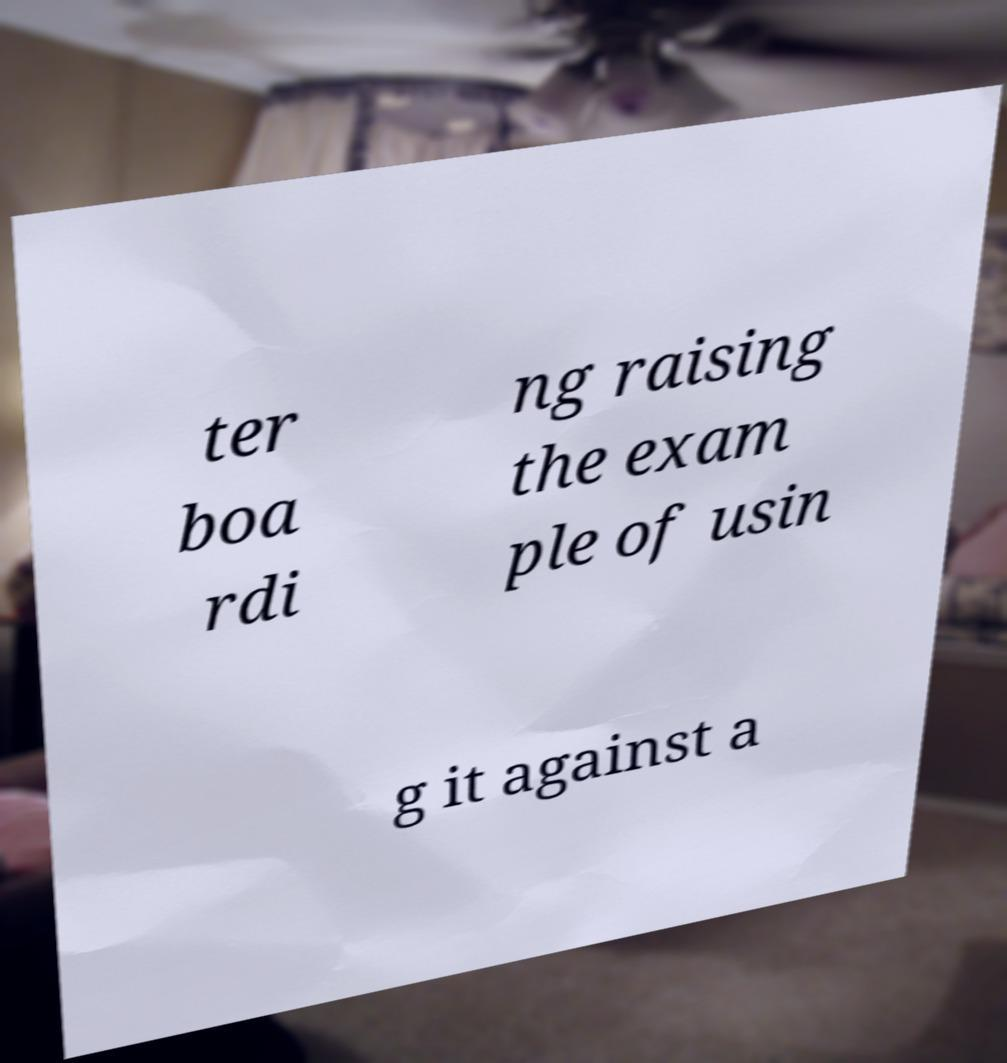Can you read and provide the text displayed in the image?This photo seems to have some interesting text. Can you extract and type it out for me? ter boa rdi ng raising the exam ple of usin g it against a 